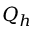Convert formula to latex. <formula><loc_0><loc_0><loc_500><loc_500>Q _ { h }</formula> 